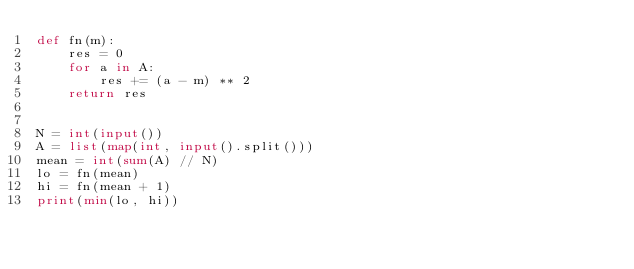<code> <loc_0><loc_0><loc_500><loc_500><_Python_>def fn(m):
    res = 0
    for a in A:
        res += (a - m) ** 2
    return res


N = int(input())
A = list(map(int, input().split()))
mean = int(sum(A) // N)
lo = fn(mean)
hi = fn(mean + 1)
print(min(lo, hi))
</code> 